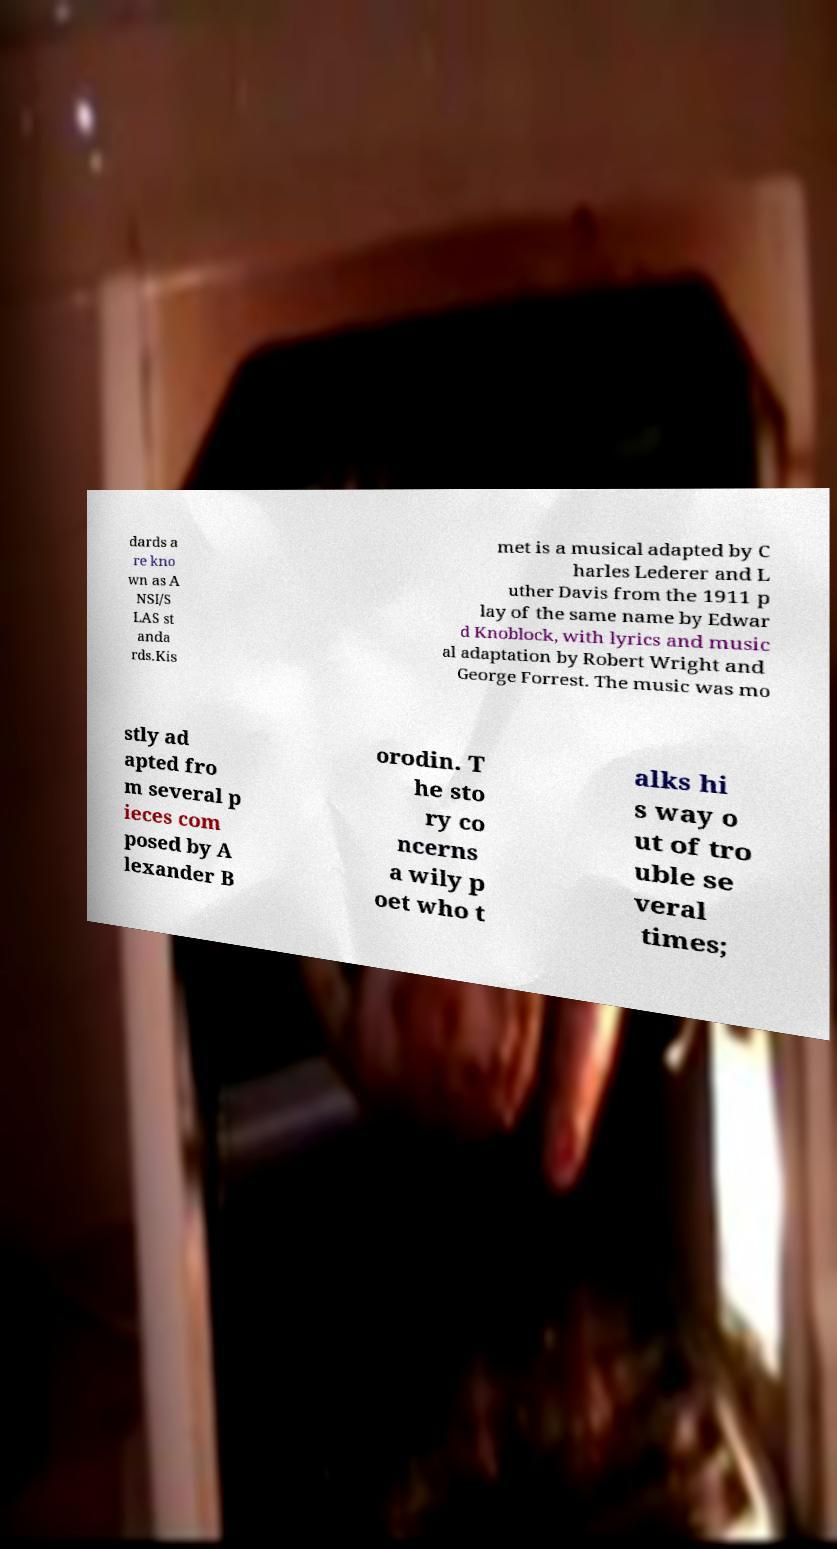Please identify and transcribe the text found in this image. dards a re kno wn as A NSI/S LAS st anda rds.Kis met is a musical adapted by C harles Lederer and L uther Davis from the 1911 p lay of the same name by Edwar d Knoblock, with lyrics and music al adaptation by Robert Wright and George Forrest. The music was mo stly ad apted fro m several p ieces com posed by A lexander B orodin. T he sto ry co ncerns a wily p oet who t alks hi s way o ut of tro uble se veral times; 